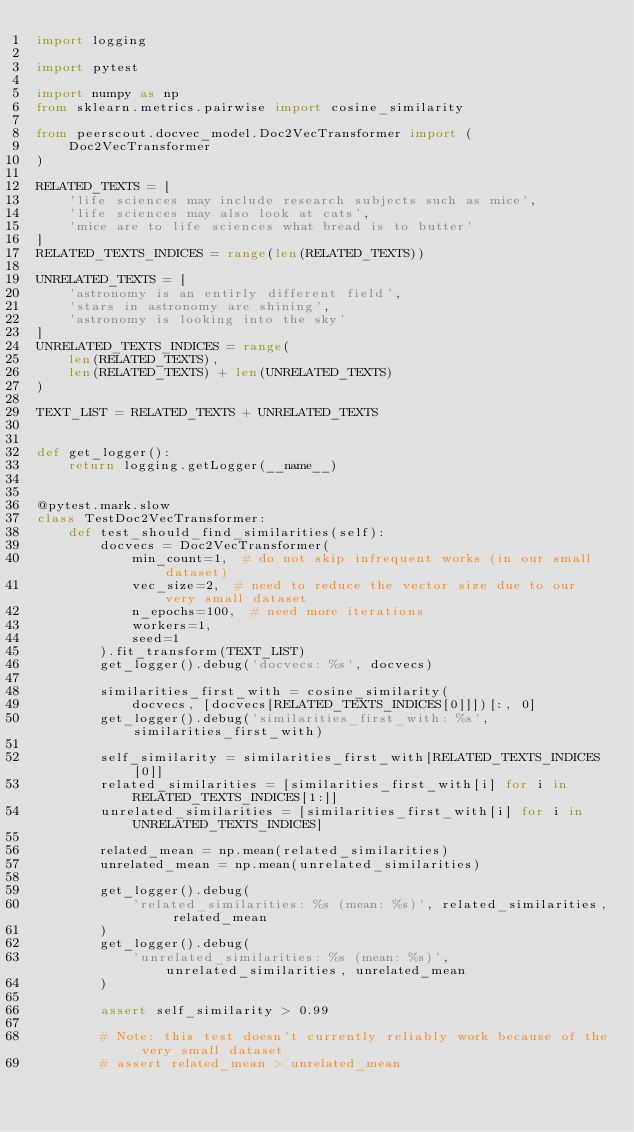Convert code to text. <code><loc_0><loc_0><loc_500><loc_500><_Python_>import logging

import pytest

import numpy as np
from sklearn.metrics.pairwise import cosine_similarity

from peerscout.docvec_model.Doc2VecTransformer import (
    Doc2VecTransformer
)

RELATED_TEXTS = [
    'life sciences may include research subjects such as mice',
    'life sciences may also look at cats',
    'mice are to life sciences what bread is to butter'
]
RELATED_TEXTS_INDICES = range(len(RELATED_TEXTS))

UNRELATED_TEXTS = [
    'astronomy is an entirly different field',
    'stars in astronomy are shining',
    'astronomy is looking into the sky'
]
UNRELATED_TEXTS_INDICES = range(
    len(RELATED_TEXTS),
    len(RELATED_TEXTS) + len(UNRELATED_TEXTS)
)

TEXT_LIST = RELATED_TEXTS + UNRELATED_TEXTS


def get_logger():
    return logging.getLogger(__name__)


@pytest.mark.slow
class TestDoc2VecTransformer:
    def test_should_find_similarities(self):
        docvecs = Doc2VecTransformer(
            min_count=1,  # do not skip infrequent works (in our small dataset)
            vec_size=2,  # need to reduce the vector size due to our very small dataset
            n_epochs=100,  # need more iterations
            workers=1,
            seed=1
        ).fit_transform(TEXT_LIST)
        get_logger().debug('docvecs: %s', docvecs)

        similarities_first_with = cosine_similarity(
            docvecs, [docvecs[RELATED_TEXTS_INDICES[0]]])[:, 0]
        get_logger().debug('similarities_first_with: %s', similarities_first_with)

        self_similarity = similarities_first_with[RELATED_TEXTS_INDICES[0]]
        related_similarities = [similarities_first_with[i] for i in RELATED_TEXTS_INDICES[1:]]
        unrelated_similarities = [similarities_first_with[i] for i in UNRELATED_TEXTS_INDICES]

        related_mean = np.mean(related_similarities)
        unrelated_mean = np.mean(unrelated_similarities)

        get_logger().debug(
            'related_similarities: %s (mean: %s)', related_similarities, related_mean
        )
        get_logger().debug(
            'unrelated_similarities: %s (mean: %s)', unrelated_similarities, unrelated_mean
        )

        assert self_similarity > 0.99

        # Note: this test doesn't currently reliably work because of the very small dataset
        # assert related_mean > unrelated_mean
</code> 